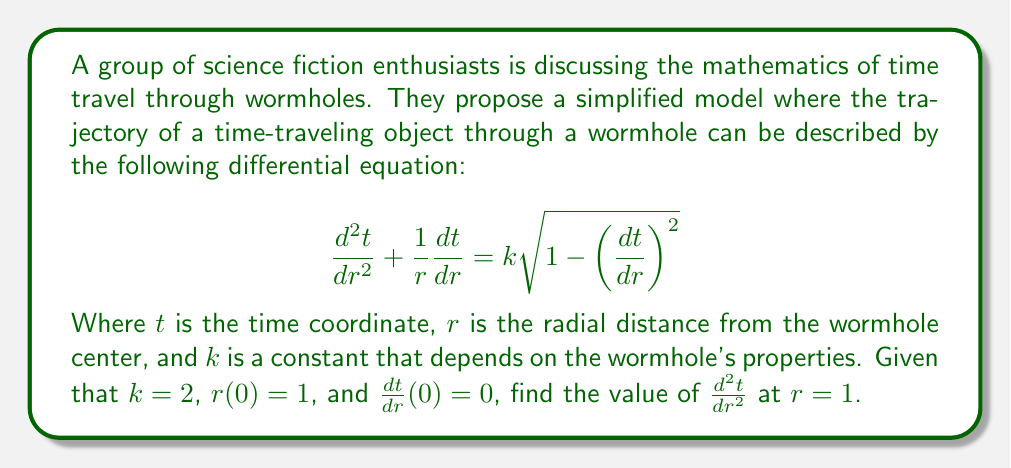Solve this math problem. To solve this problem, we need to follow these steps:

1) First, let's simplify our notation by setting $y=t$ and $y'=\frac{dt}{dr}$. Our equation becomes:

   $$y'' + \frac{1}{r}y' = k\sqrt{1-(y')^2}$$

2) We're given that $k=2$, so we can substitute this:

   $$y'' + \frac{1}{r}y' = 2\sqrt{1-(y')^2}$$

3) We're also given that $r(0)=1$, which means we're evaluating the equation at $r=1$:

   $$y'' + y' = 2\sqrt{1-(y')^2}$$

4) Finally, we're told that $y'(0)=0$. Let's substitute this:

   $$y'' + 0 = 2\sqrt{1-0^2}$$

5) Simplify:

   $$y'' = 2\sqrt{1} = 2$$

6) Therefore, at $r=1$, $\frac{d^2t}{dr^2} = 2$.

This result tells us that at the entrance of the wormhole (assuming $r=1$ is the entrance), the rate of change of the time coordinate is increasing at a constant rate with respect to the radial distance.
Answer: $\frac{d^2t}{dr^2} = 2$ at $r=1$ 